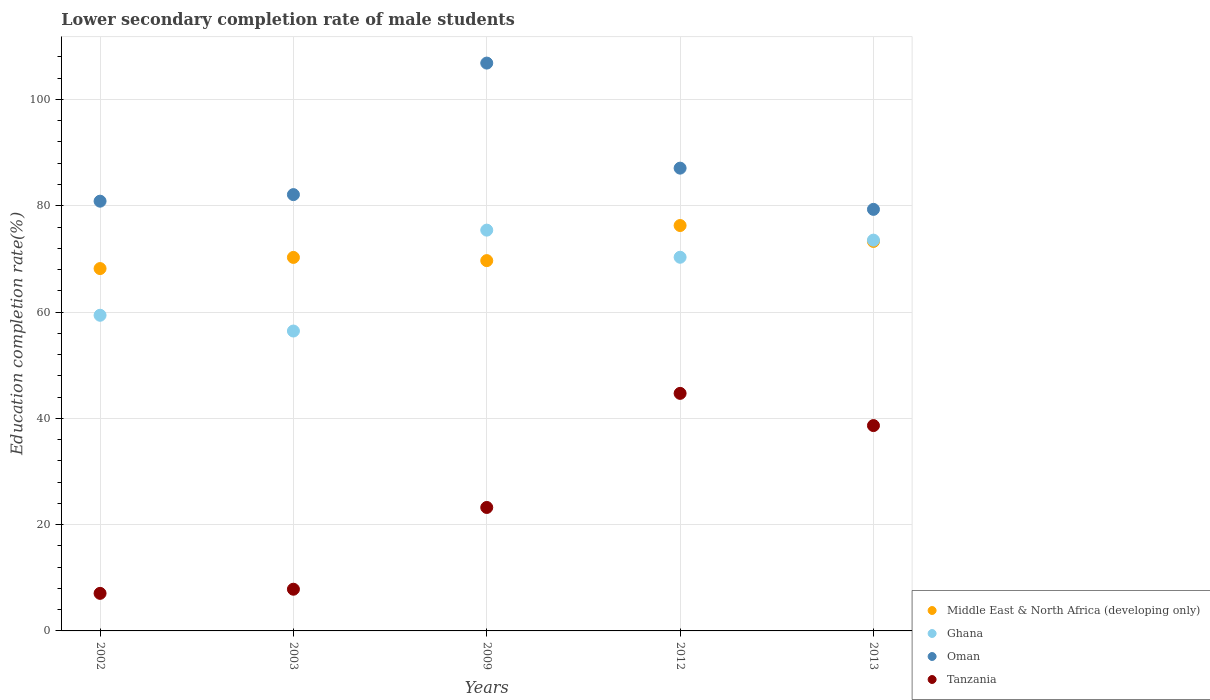Is the number of dotlines equal to the number of legend labels?
Give a very brief answer. Yes. What is the lower secondary completion rate of male students in Middle East & North Africa (developing only) in 2002?
Provide a short and direct response. 68.18. Across all years, what is the maximum lower secondary completion rate of male students in Tanzania?
Keep it short and to the point. 44.7. Across all years, what is the minimum lower secondary completion rate of male students in Ghana?
Offer a terse response. 56.43. In which year was the lower secondary completion rate of male students in Middle East & North Africa (developing only) maximum?
Offer a terse response. 2012. In which year was the lower secondary completion rate of male students in Tanzania minimum?
Your response must be concise. 2002. What is the total lower secondary completion rate of male students in Tanzania in the graph?
Keep it short and to the point. 121.48. What is the difference between the lower secondary completion rate of male students in Ghana in 2002 and that in 2009?
Give a very brief answer. -16.02. What is the difference between the lower secondary completion rate of male students in Ghana in 2003 and the lower secondary completion rate of male students in Oman in 2012?
Your response must be concise. -30.65. What is the average lower secondary completion rate of male students in Ghana per year?
Your answer should be compact. 67.02. In the year 2002, what is the difference between the lower secondary completion rate of male students in Tanzania and lower secondary completion rate of male students in Oman?
Provide a short and direct response. -73.79. In how many years, is the lower secondary completion rate of male students in Oman greater than 4 %?
Make the answer very short. 5. What is the ratio of the lower secondary completion rate of male students in Tanzania in 2002 to that in 2009?
Offer a very short reply. 0.3. Is the lower secondary completion rate of male students in Oman in 2009 less than that in 2012?
Give a very brief answer. No. What is the difference between the highest and the second highest lower secondary completion rate of male students in Oman?
Offer a terse response. 19.77. What is the difference between the highest and the lowest lower secondary completion rate of male students in Ghana?
Your answer should be compact. 18.98. In how many years, is the lower secondary completion rate of male students in Ghana greater than the average lower secondary completion rate of male students in Ghana taken over all years?
Provide a succinct answer. 3. Is it the case that in every year, the sum of the lower secondary completion rate of male students in Tanzania and lower secondary completion rate of male students in Ghana  is greater than the sum of lower secondary completion rate of male students in Middle East & North Africa (developing only) and lower secondary completion rate of male students in Oman?
Ensure brevity in your answer.  No. Does the lower secondary completion rate of male students in Middle East & North Africa (developing only) monotonically increase over the years?
Make the answer very short. No. How many years are there in the graph?
Offer a terse response. 5. What is the difference between two consecutive major ticks on the Y-axis?
Provide a short and direct response. 20. Are the values on the major ticks of Y-axis written in scientific E-notation?
Offer a very short reply. No. How many legend labels are there?
Ensure brevity in your answer.  4. What is the title of the graph?
Your response must be concise. Lower secondary completion rate of male students. What is the label or title of the X-axis?
Keep it short and to the point. Years. What is the label or title of the Y-axis?
Give a very brief answer. Education completion rate(%). What is the Education completion rate(%) of Middle East & North Africa (developing only) in 2002?
Give a very brief answer. 68.18. What is the Education completion rate(%) in Ghana in 2002?
Your response must be concise. 59.39. What is the Education completion rate(%) in Oman in 2002?
Offer a very short reply. 80.86. What is the Education completion rate(%) in Tanzania in 2002?
Provide a succinct answer. 7.07. What is the Education completion rate(%) in Middle East & North Africa (developing only) in 2003?
Offer a very short reply. 70.28. What is the Education completion rate(%) in Ghana in 2003?
Make the answer very short. 56.43. What is the Education completion rate(%) of Oman in 2003?
Make the answer very short. 82.1. What is the Education completion rate(%) of Tanzania in 2003?
Provide a short and direct response. 7.85. What is the Education completion rate(%) of Middle East & North Africa (developing only) in 2009?
Offer a very short reply. 69.68. What is the Education completion rate(%) in Ghana in 2009?
Your response must be concise. 75.41. What is the Education completion rate(%) of Oman in 2009?
Your answer should be very brief. 106.85. What is the Education completion rate(%) of Tanzania in 2009?
Your response must be concise. 23.23. What is the Education completion rate(%) in Middle East & North Africa (developing only) in 2012?
Give a very brief answer. 76.28. What is the Education completion rate(%) in Ghana in 2012?
Offer a terse response. 70.31. What is the Education completion rate(%) of Oman in 2012?
Your answer should be compact. 87.08. What is the Education completion rate(%) in Tanzania in 2012?
Your answer should be compact. 44.7. What is the Education completion rate(%) in Middle East & North Africa (developing only) in 2013?
Provide a short and direct response. 73.28. What is the Education completion rate(%) of Ghana in 2013?
Give a very brief answer. 73.53. What is the Education completion rate(%) of Oman in 2013?
Your answer should be very brief. 79.32. What is the Education completion rate(%) of Tanzania in 2013?
Offer a very short reply. 38.64. Across all years, what is the maximum Education completion rate(%) in Middle East & North Africa (developing only)?
Your response must be concise. 76.28. Across all years, what is the maximum Education completion rate(%) in Ghana?
Ensure brevity in your answer.  75.41. Across all years, what is the maximum Education completion rate(%) in Oman?
Offer a terse response. 106.85. Across all years, what is the maximum Education completion rate(%) in Tanzania?
Provide a short and direct response. 44.7. Across all years, what is the minimum Education completion rate(%) in Middle East & North Africa (developing only)?
Your response must be concise. 68.18. Across all years, what is the minimum Education completion rate(%) in Ghana?
Give a very brief answer. 56.43. Across all years, what is the minimum Education completion rate(%) of Oman?
Keep it short and to the point. 79.32. Across all years, what is the minimum Education completion rate(%) of Tanzania?
Give a very brief answer. 7.07. What is the total Education completion rate(%) of Middle East & North Africa (developing only) in the graph?
Give a very brief answer. 357.7. What is the total Education completion rate(%) of Ghana in the graph?
Give a very brief answer. 335.08. What is the total Education completion rate(%) in Oman in the graph?
Ensure brevity in your answer.  436.2. What is the total Education completion rate(%) in Tanzania in the graph?
Keep it short and to the point. 121.48. What is the difference between the Education completion rate(%) in Middle East & North Africa (developing only) in 2002 and that in 2003?
Provide a short and direct response. -2.1. What is the difference between the Education completion rate(%) in Ghana in 2002 and that in 2003?
Your response must be concise. 2.97. What is the difference between the Education completion rate(%) in Oman in 2002 and that in 2003?
Offer a very short reply. -1.23. What is the difference between the Education completion rate(%) of Tanzania in 2002 and that in 2003?
Offer a terse response. -0.78. What is the difference between the Education completion rate(%) in Middle East & North Africa (developing only) in 2002 and that in 2009?
Offer a very short reply. -1.49. What is the difference between the Education completion rate(%) of Ghana in 2002 and that in 2009?
Offer a very short reply. -16.02. What is the difference between the Education completion rate(%) of Oman in 2002 and that in 2009?
Provide a succinct answer. -25.98. What is the difference between the Education completion rate(%) of Tanzania in 2002 and that in 2009?
Your answer should be compact. -16.16. What is the difference between the Education completion rate(%) in Middle East & North Africa (developing only) in 2002 and that in 2012?
Provide a succinct answer. -8.1. What is the difference between the Education completion rate(%) in Ghana in 2002 and that in 2012?
Your response must be concise. -10.92. What is the difference between the Education completion rate(%) in Oman in 2002 and that in 2012?
Your answer should be compact. -6.22. What is the difference between the Education completion rate(%) of Tanzania in 2002 and that in 2012?
Your answer should be very brief. -37.63. What is the difference between the Education completion rate(%) of Middle East & North Africa (developing only) in 2002 and that in 2013?
Offer a terse response. -5.1. What is the difference between the Education completion rate(%) of Ghana in 2002 and that in 2013?
Give a very brief answer. -14.14. What is the difference between the Education completion rate(%) of Oman in 2002 and that in 2013?
Give a very brief answer. 1.54. What is the difference between the Education completion rate(%) in Tanzania in 2002 and that in 2013?
Provide a short and direct response. -31.57. What is the difference between the Education completion rate(%) in Middle East & North Africa (developing only) in 2003 and that in 2009?
Give a very brief answer. 0.6. What is the difference between the Education completion rate(%) in Ghana in 2003 and that in 2009?
Offer a terse response. -18.98. What is the difference between the Education completion rate(%) of Oman in 2003 and that in 2009?
Your response must be concise. -24.75. What is the difference between the Education completion rate(%) of Tanzania in 2003 and that in 2009?
Give a very brief answer. -15.38. What is the difference between the Education completion rate(%) of Middle East & North Africa (developing only) in 2003 and that in 2012?
Ensure brevity in your answer.  -6. What is the difference between the Education completion rate(%) of Ghana in 2003 and that in 2012?
Make the answer very short. -13.88. What is the difference between the Education completion rate(%) of Oman in 2003 and that in 2012?
Ensure brevity in your answer.  -4.98. What is the difference between the Education completion rate(%) in Tanzania in 2003 and that in 2012?
Offer a very short reply. -36.85. What is the difference between the Education completion rate(%) in Middle East & North Africa (developing only) in 2003 and that in 2013?
Keep it short and to the point. -3.01. What is the difference between the Education completion rate(%) in Ghana in 2003 and that in 2013?
Offer a very short reply. -17.1. What is the difference between the Education completion rate(%) of Oman in 2003 and that in 2013?
Your response must be concise. 2.77. What is the difference between the Education completion rate(%) of Tanzania in 2003 and that in 2013?
Offer a terse response. -30.79. What is the difference between the Education completion rate(%) of Middle East & North Africa (developing only) in 2009 and that in 2012?
Keep it short and to the point. -6.6. What is the difference between the Education completion rate(%) in Ghana in 2009 and that in 2012?
Your response must be concise. 5.1. What is the difference between the Education completion rate(%) in Oman in 2009 and that in 2012?
Provide a short and direct response. 19.77. What is the difference between the Education completion rate(%) in Tanzania in 2009 and that in 2012?
Offer a terse response. -21.47. What is the difference between the Education completion rate(%) in Middle East & North Africa (developing only) in 2009 and that in 2013?
Provide a succinct answer. -3.61. What is the difference between the Education completion rate(%) of Ghana in 2009 and that in 2013?
Offer a terse response. 1.88. What is the difference between the Education completion rate(%) of Oman in 2009 and that in 2013?
Make the answer very short. 27.52. What is the difference between the Education completion rate(%) in Tanzania in 2009 and that in 2013?
Your answer should be very brief. -15.41. What is the difference between the Education completion rate(%) of Middle East & North Africa (developing only) in 2012 and that in 2013?
Make the answer very short. 3. What is the difference between the Education completion rate(%) of Ghana in 2012 and that in 2013?
Your answer should be very brief. -3.22. What is the difference between the Education completion rate(%) in Oman in 2012 and that in 2013?
Provide a short and direct response. 7.76. What is the difference between the Education completion rate(%) of Tanzania in 2012 and that in 2013?
Give a very brief answer. 6.06. What is the difference between the Education completion rate(%) of Middle East & North Africa (developing only) in 2002 and the Education completion rate(%) of Ghana in 2003?
Your answer should be compact. 11.75. What is the difference between the Education completion rate(%) in Middle East & North Africa (developing only) in 2002 and the Education completion rate(%) in Oman in 2003?
Your response must be concise. -13.91. What is the difference between the Education completion rate(%) of Middle East & North Africa (developing only) in 2002 and the Education completion rate(%) of Tanzania in 2003?
Provide a succinct answer. 60.34. What is the difference between the Education completion rate(%) in Ghana in 2002 and the Education completion rate(%) in Oman in 2003?
Provide a succinct answer. -22.7. What is the difference between the Education completion rate(%) in Ghana in 2002 and the Education completion rate(%) in Tanzania in 2003?
Provide a succinct answer. 51.55. What is the difference between the Education completion rate(%) of Oman in 2002 and the Education completion rate(%) of Tanzania in 2003?
Your response must be concise. 73.01. What is the difference between the Education completion rate(%) in Middle East & North Africa (developing only) in 2002 and the Education completion rate(%) in Ghana in 2009?
Make the answer very short. -7.23. What is the difference between the Education completion rate(%) in Middle East & North Africa (developing only) in 2002 and the Education completion rate(%) in Oman in 2009?
Your answer should be compact. -38.66. What is the difference between the Education completion rate(%) of Middle East & North Africa (developing only) in 2002 and the Education completion rate(%) of Tanzania in 2009?
Provide a succinct answer. 44.95. What is the difference between the Education completion rate(%) in Ghana in 2002 and the Education completion rate(%) in Oman in 2009?
Your response must be concise. -47.45. What is the difference between the Education completion rate(%) of Ghana in 2002 and the Education completion rate(%) of Tanzania in 2009?
Ensure brevity in your answer.  36.16. What is the difference between the Education completion rate(%) of Oman in 2002 and the Education completion rate(%) of Tanzania in 2009?
Keep it short and to the point. 57.63. What is the difference between the Education completion rate(%) in Middle East & North Africa (developing only) in 2002 and the Education completion rate(%) in Ghana in 2012?
Provide a succinct answer. -2.13. What is the difference between the Education completion rate(%) of Middle East & North Africa (developing only) in 2002 and the Education completion rate(%) of Oman in 2012?
Your response must be concise. -18.9. What is the difference between the Education completion rate(%) of Middle East & North Africa (developing only) in 2002 and the Education completion rate(%) of Tanzania in 2012?
Your answer should be compact. 23.48. What is the difference between the Education completion rate(%) of Ghana in 2002 and the Education completion rate(%) of Oman in 2012?
Offer a very short reply. -27.68. What is the difference between the Education completion rate(%) of Ghana in 2002 and the Education completion rate(%) of Tanzania in 2012?
Give a very brief answer. 14.7. What is the difference between the Education completion rate(%) in Oman in 2002 and the Education completion rate(%) in Tanzania in 2012?
Your answer should be very brief. 36.16. What is the difference between the Education completion rate(%) of Middle East & North Africa (developing only) in 2002 and the Education completion rate(%) of Ghana in 2013?
Offer a terse response. -5.35. What is the difference between the Education completion rate(%) in Middle East & North Africa (developing only) in 2002 and the Education completion rate(%) in Oman in 2013?
Make the answer very short. -11.14. What is the difference between the Education completion rate(%) of Middle East & North Africa (developing only) in 2002 and the Education completion rate(%) of Tanzania in 2013?
Keep it short and to the point. 29.54. What is the difference between the Education completion rate(%) of Ghana in 2002 and the Education completion rate(%) of Oman in 2013?
Your answer should be compact. -19.93. What is the difference between the Education completion rate(%) in Ghana in 2002 and the Education completion rate(%) in Tanzania in 2013?
Ensure brevity in your answer.  20.76. What is the difference between the Education completion rate(%) of Oman in 2002 and the Education completion rate(%) of Tanzania in 2013?
Your response must be concise. 42.22. What is the difference between the Education completion rate(%) of Middle East & North Africa (developing only) in 2003 and the Education completion rate(%) of Ghana in 2009?
Offer a terse response. -5.13. What is the difference between the Education completion rate(%) in Middle East & North Africa (developing only) in 2003 and the Education completion rate(%) in Oman in 2009?
Give a very brief answer. -36.57. What is the difference between the Education completion rate(%) of Middle East & North Africa (developing only) in 2003 and the Education completion rate(%) of Tanzania in 2009?
Offer a very short reply. 47.05. What is the difference between the Education completion rate(%) in Ghana in 2003 and the Education completion rate(%) in Oman in 2009?
Your answer should be very brief. -50.42. What is the difference between the Education completion rate(%) of Ghana in 2003 and the Education completion rate(%) of Tanzania in 2009?
Your response must be concise. 33.2. What is the difference between the Education completion rate(%) in Oman in 2003 and the Education completion rate(%) in Tanzania in 2009?
Your response must be concise. 58.86. What is the difference between the Education completion rate(%) of Middle East & North Africa (developing only) in 2003 and the Education completion rate(%) of Ghana in 2012?
Your answer should be compact. -0.03. What is the difference between the Education completion rate(%) of Middle East & North Africa (developing only) in 2003 and the Education completion rate(%) of Oman in 2012?
Provide a short and direct response. -16.8. What is the difference between the Education completion rate(%) of Middle East & North Africa (developing only) in 2003 and the Education completion rate(%) of Tanzania in 2012?
Provide a short and direct response. 25.58. What is the difference between the Education completion rate(%) of Ghana in 2003 and the Education completion rate(%) of Oman in 2012?
Provide a succinct answer. -30.65. What is the difference between the Education completion rate(%) in Ghana in 2003 and the Education completion rate(%) in Tanzania in 2012?
Offer a terse response. 11.73. What is the difference between the Education completion rate(%) in Oman in 2003 and the Education completion rate(%) in Tanzania in 2012?
Provide a succinct answer. 37.4. What is the difference between the Education completion rate(%) in Middle East & North Africa (developing only) in 2003 and the Education completion rate(%) in Ghana in 2013?
Ensure brevity in your answer.  -3.25. What is the difference between the Education completion rate(%) in Middle East & North Africa (developing only) in 2003 and the Education completion rate(%) in Oman in 2013?
Ensure brevity in your answer.  -9.04. What is the difference between the Education completion rate(%) of Middle East & North Africa (developing only) in 2003 and the Education completion rate(%) of Tanzania in 2013?
Your answer should be compact. 31.64. What is the difference between the Education completion rate(%) of Ghana in 2003 and the Education completion rate(%) of Oman in 2013?
Keep it short and to the point. -22.89. What is the difference between the Education completion rate(%) of Ghana in 2003 and the Education completion rate(%) of Tanzania in 2013?
Offer a terse response. 17.79. What is the difference between the Education completion rate(%) of Oman in 2003 and the Education completion rate(%) of Tanzania in 2013?
Give a very brief answer. 43.46. What is the difference between the Education completion rate(%) of Middle East & North Africa (developing only) in 2009 and the Education completion rate(%) of Ghana in 2012?
Keep it short and to the point. -0.63. What is the difference between the Education completion rate(%) of Middle East & North Africa (developing only) in 2009 and the Education completion rate(%) of Oman in 2012?
Your response must be concise. -17.4. What is the difference between the Education completion rate(%) in Middle East & North Africa (developing only) in 2009 and the Education completion rate(%) in Tanzania in 2012?
Your response must be concise. 24.98. What is the difference between the Education completion rate(%) in Ghana in 2009 and the Education completion rate(%) in Oman in 2012?
Your answer should be compact. -11.67. What is the difference between the Education completion rate(%) of Ghana in 2009 and the Education completion rate(%) of Tanzania in 2012?
Offer a terse response. 30.72. What is the difference between the Education completion rate(%) in Oman in 2009 and the Education completion rate(%) in Tanzania in 2012?
Provide a short and direct response. 62.15. What is the difference between the Education completion rate(%) of Middle East & North Africa (developing only) in 2009 and the Education completion rate(%) of Ghana in 2013?
Make the answer very short. -3.85. What is the difference between the Education completion rate(%) in Middle East & North Africa (developing only) in 2009 and the Education completion rate(%) in Oman in 2013?
Offer a terse response. -9.64. What is the difference between the Education completion rate(%) in Middle East & North Africa (developing only) in 2009 and the Education completion rate(%) in Tanzania in 2013?
Your response must be concise. 31.04. What is the difference between the Education completion rate(%) in Ghana in 2009 and the Education completion rate(%) in Oman in 2013?
Keep it short and to the point. -3.91. What is the difference between the Education completion rate(%) in Ghana in 2009 and the Education completion rate(%) in Tanzania in 2013?
Provide a short and direct response. 36.77. What is the difference between the Education completion rate(%) in Oman in 2009 and the Education completion rate(%) in Tanzania in 2013?
Keep it short and to the point. 68.21. What is the difference between the Education completion rate(%) of Middle East & North Africa (developing only) in 2012 and the Education completion rate(%) of Ghana in 2013?
Your response must be concise. 2.75. What is the difference between the Education completion rate(%) of Middle East & North Africa (developing only) in 2012 and the Education completion rate(%) of Oman in 2013?
Keep it short and to the point. -3.04. What is the difference between the Education completion rate(%) in Middle East & North Africa (developing only) in 2012 and the Education completion rate(%) in Tanzania in 2013?
Give a very brief answer. 37.64. What is the difference between the Education completion rate(%) of Ghana in 2012 and the Education completion rate(%) of Oman in 2013?
Ensure brevity in your answer.  -9.01. What is the difference between the Education completion rate(%) of Ghana in 2012 and the Education completion rate(%) of Tanzania in 2013?
Offer a very short reply. 31.67. What is the difference between the Education completion rate(%) of Oman in 2012 and the Education completion rate(%) of Tanzania in 2013?
Your answer should be compact. 48.44. What is the average Education completion rate(%) in Middle East & North Africa (developing only) per year?
Ensure brevity in your answer.  71.54. What is the average Education completion rate(%) in Ghana per year?
Offer a very short reply. 67.02. What is the average Education completion rate(%) of Oman per year?
Your answer should be compact. 87.24. What is the average Education completion rate(%) in Tanzania per year?
Your answer should be very brief. 24.3. In the year 2002, what is the difference between the Education completion rate(%) of Middle East & North Africa (developing only) and Education completion rate(%) of Ghana?
Your answer should be compact. 8.79. In the year 2002, what is the difference between the Education completion rate(%) of Middle East & North Africa (developing only) and Education completion rate(%) of Oman?
Give a very brief answer. -12.68. In the year 2002, what is the difference between the Education completion rate(%) in Middle East & North Africa (developing only) and Education completion rate(%) in Tanzania?
Offer a very short reply. 61.11. In the year 2002, what is the difference between the Education completion rate(%) in Ghana and Education completion rate(%) in Oman?
Offer a terse response. -21.47. In the year 2002, what is the difference between the Education completion rate(%) of Ghana and Education completion rate(%) of Tanzania?
Your answer should be very brief. 52.33. In the year 2002, what is the difference between the Education completion rate(%) of Oman and Education completion rate(%) of Tanzania?
Your answer should be compact. 73.79. In the year 2003, what is the difference between the Education completion rate(%) in Middle East & North Africa (developing only) and Education completion rate(%) in Ghana?
Ensure brevity in your answer.  13.85. In the year 2003, what is the difference between the Education completion rate(%) in Middle East & North Africa (developing only) and Education completion rate(%) in Oman?
Make the answer very short. -11.82. In the year 2003, what is the difference between the Education completion rate(%) of Middle East & North Africa (developing only) and Education completion rate(%) of Tanzania?
Ensure brevity in your answer.  62.43. In the year 2003, what is the difference between the Education completion rate(%) in Ghana and Education completion rate(%) in Oman?
Your answer should be very brief. -25.67. In the year 2003, what is the difference between the Education completion rate(%) of Ghana and Education completion rate(%) of Tanzania?
Make the answer very short. 48.58. In the year 2003, what is the difference between the Education completion rate(%) in Oman and Education completion rate(%) in Tanzania?
Ensure brevity in your answer.  74.25. In the year 2009, what is the difference between the Education completion rate(%) of Middle East & North Africa (developing only) and Education completion rate(%) of Ghana?
Offer a very short reply. -5.74. In the year 2009, what is the difference between the Education completion rate(%) in Middle East & North Africa (developing only) and Education completion rate(%) in Oman?
Your answer should be very brief. -37.17. In the year 2009, what is the difference between the Education completion rate(%) in Middle East & North Africa (developing only) and Education completion rate(%) in Tanzania?
Your answer should be compact. 46.45. In the year 2009, what is the difference between the Education completion rate(%) in Ghana and Education completion rate(%) in Oman?
Keep it short and to the point. -31.43. In the year 2009, what is the difference between the Education completion rate(%) in Ghana and Education completion rate(%) in Tanzania?
Give a very brief answer. 52.18. In the year 2009, what is the difference between the Education completion rate(%) of Oman and Education completion rate(%) of Tanzania?
Offer a very short reply. 83.61. In the year 2012, what is the difference between the Education completion rate(%) in Middle East & North Africa (developing only) and Education completion rate(%) in Ghana?
Your answer should be compact. 5.97. In the year 2012, what is the difference between the Education completion rate(%) of Middle East & North Africa (developing only) and Education completion rate(%) of Oman?
Your response must be concise. -10.8. In the year 2012, what is the difference between the Education completion rate(%) of Middle East & North Africa (developing only) and Education completion rate(%) of Tanzania?
Give a very brief answer. 31.58. In the year 2012, what is the difference between the Education completion rate(%) of Ghana and Education completion rate(%) of Oman?
Your answer should be very brief. -16.77. In the year 2012, what is the difference between the Education completion rate(%) of Ghana and Education completion rate(%) of Tanzania?
Your answer should be compact. 25.61. In the year 2012, what is the difference between the Education completion rate(%) in Oman and Education completion rate(%) in Tanzania?
Offer a terse response. 42.38. In the year 2013, what is the difference between the Education completion rate(%) in Middle East & North Africa (developing only) and Education completion rate(%) in Ghana?
Your response must be concise. -0.25. In the year 2013, what is the difference between the Education completion rate(%) in Middle East & North Africa (developing only) and Education completion rate(%) in Oman?
Your answer should be very brief. -6.04. In the year 2013, what is the difference between the Education completion rate(%) in Middle East & North Africa (developing only) and Education completion rate(%) in Tanzania?
Keep it short and to the point. 34.65. In the year 2013, what is the difference between the Education completion rate(%) of Ghana and Education completion rate(%) of Oman?
Keep it short and to the point. -5.79. In the year 2013, what is the difference between the Education completion rate(%) of Ghana and Education completion rate(%) of Tanzania?
Offer a very short reply. 34.89. In the year 2013, what is the difference between the Education completion rate(%) in Oman and Education completion rate(%) in Tanzania?
Give a very brief answer. 40.68. What is the ratio of the Education completion rate(%) in Middle East & North Africa (developing only) in 2002 to that in 2003?
Offer a very short reply. 0.97. What is the ratio of the Education completion rate(%) of Ghana in 2002 to that in 2003?
Ensure brevity in your answer.  1.05. What is the ratio of the Education completion rate(%) of Tanzania in 2002 to that in 2003?
Keep it short and to the point. 0.9. What is the ratio of the Education completion rate(%) of Middle East & North Africa (developing only) in 2002 to that in 2009?
Keep it short and to the point. 0.98. What is the ratio of the Education completion rate(%) in Ghana in 2002 to that in 2009?
Keep it short and to the point. 0.79. What is the ratio of the Education completion rate(%) of Oman in 2002 to that in 2009?
Offer a terse response. 0.76. What is the ratio of the Education completion rate(%) in Tanzania in 2002 to that in 2009?
Give a very brief answer. 0.3. What is the ratio of the Education completion rate(%) in Middle East & North Africa (developing only) in 2002 to that in 2012?
Make the answer very short. 0.89. What is the ratio of the Education completion rate(%) of Ghana in 2002 to that in 2012?
Keep it short and to the point. 0.84. What is the ratio of the Education completion rate(%) of Tanzania in 2002 to that in 2012?
Keep it short and to the point. 0.16. What is the ratio of the Education completion rate(%) in Middle East & North Africa (developing only) in 2002 to that in 2013?
Provide a short and direct response. 0.93. What is the ratio of the Education completion rate(%) of Ghana in 2002 to that in 2013?
Ensure brevity in your answer.  0.81. What is the ratio of the Education completion rate(%) in Oman in 2002 to that in 2013?
Provide a succinct answer. 1.02. What is the ratio of the Education completion rate(%) in Tanzania in 2002 to that in 2013?
Your answer should be compact. 0.18. What is the ratio of the Education completion rate(%) of Middle East & North Africa (developing only) in 2003 to that in 2009?
Your answer should be compact. 1.01. What is the ratio of the Education completion rate(%) in Ghana in 2003 to that in 2009?
Your answer should be compact. 0.75. What is the ratio of the Education completion rate(%) in Oman in 2003 to that in 2009?
Keep it short and to the point. 0.77. What is the ratio of the Education completion rate(%) in Tanzania in 2003 to that in 2009?
Offer a very short reply. 0.34. What is the ratio of the Education completion rate(%) of Middle East & North Africa (developing only) in 2003 to that in 2012?
Your response must be concise. 0.92. What is the ratio of the Education completion rate(%) in Ghana in 2003 to that in 2012?
Provide a short and direct response. 0.8. What is the ratio of the Education completion rate(%) of Oman in 2003 to that in 2012?
Your answer should be very brief. 0.94. What is the ratio of the Education completion rate(%) of Tanzania in 2003 to that in 2012?
Make the answer very short. 0.18. What is the ratio of the Education completion rate(%) in Middle East & North Africa (developing only) in 2003 to that in 2013?
Offer a very short reply. 0.96. What is the ratio of the Education completion rate(%) of Ghana in 2003 to that in 2013?
Give a very brief answer. 0.77. What is the ratio of the Education completion rate(%) in Oman in 2003 to that in 2013?
Offer a terse response. 1.03. What is the ratio of the Education completion rate(%) of Tanzania in 2003 to that in 2013?
Ensure brevity in your answer.  0.2. What is the ratio of the Education completion rate(%) in Middle East & North Africa (developing only) in 2009 to that in 2012?
Your response must be concise. 0.91. What is the ratio of the Education completion rate(%) in Ghana in 2009 to that in 2012?
Give a very brief answer. 1.07. What is the ratio of the Education completion rate(%) in Oman in 2009 to that in 2012?
Ensure brevity in your answer.  1.23. What is the ratio of the Education completion rate(%) in Tanzania in 2009 to that in 2012?
Keep it short and to the point. 0.52. What is the ratio of the Education completion rate(%) in Middle East & North Africa (developing only) in 2009 to that in 2013?
Your answer should be compact. 0.95. What is the ratio of the Education completion rate(%) of Ghana in 2009 to that in 2013?
Offer a terse response. 1.03. What is the ratio of the Education completion rate(%) in Oman in 2009 to that in 2013?
Make the answer very short. 1.35. What is the ratio of the Education completion rate(%) in Tanzania in 2009 to that in 2013?
Your response must be concise. 0.6. What is the ratio of the Education completion rate(%) of Middle East & North Africa (developing only) in 2012 to that in 2013?
Give a very brief answer. 1.04. What is the ratio of the Education completion rate(%) of Ghana in 2012 to that in 2013?
Offer a very short reply. 0.96. What is the ratio of the Education completion rate(%) in Oman in 2012 to that in 2013?
Keep it short and to the point. 1.1. What is the ratio of the Education completion rate(%) in Tanzania in 2012 to that in 2013?
Ensure brevity in your answer.  1.16. What is the difference between the highest and the second highest Education completion rate(%) of Middle East & North Africa (developing only)?
Your answer should be compact. 3. What is the difference between the highest and the second highest Education completion rate(%) in Ghana?
Offer a terse response. 1.88. What is the difference between the highest and the second highest Education completion rate(%) of Oman?
Your answer should be very brief. 19.77. What is the difference between the highest and the second highest Education completion rate(%) in Tanzania?
Provide a short and direct response. 6.06. What is the difference between the highest and the lowest Education completion rate(%) of Middle East & North Africa (developing only)?
Offer a terse response. 8.1. What is the difference between the highest and the lowest Education completion rate(%) in Ghana?
Make the answer very short. 18.98. What is the difference between the highest and the lowest Education completion rate(%) of Oman?
Your answer should be very brief. 27.52. What is the difference between the highest and the lowest Education completion rate(%) in Tanzania?
Your answer should be compact. 37.63. 